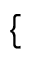Convert formula to latex. <formula><loc_0><loc_0><loc_500><loc_500>\{</formula> 